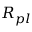<formula> <loc_0><loc_0><loc_500><loc_500>R _ { p l }</formula> 